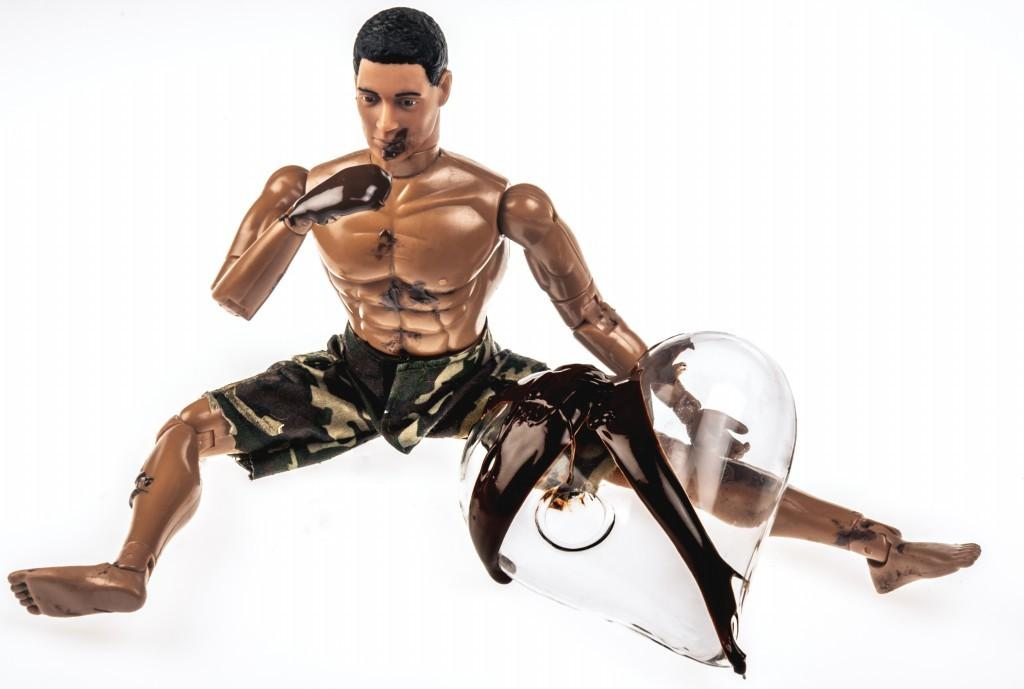What is the main subject of the image? The main subject of the image is a robot. What type of chin can be seen on the robot in the image? There is no chin present on the robot in the image, as robots do not have human-like facial features. 